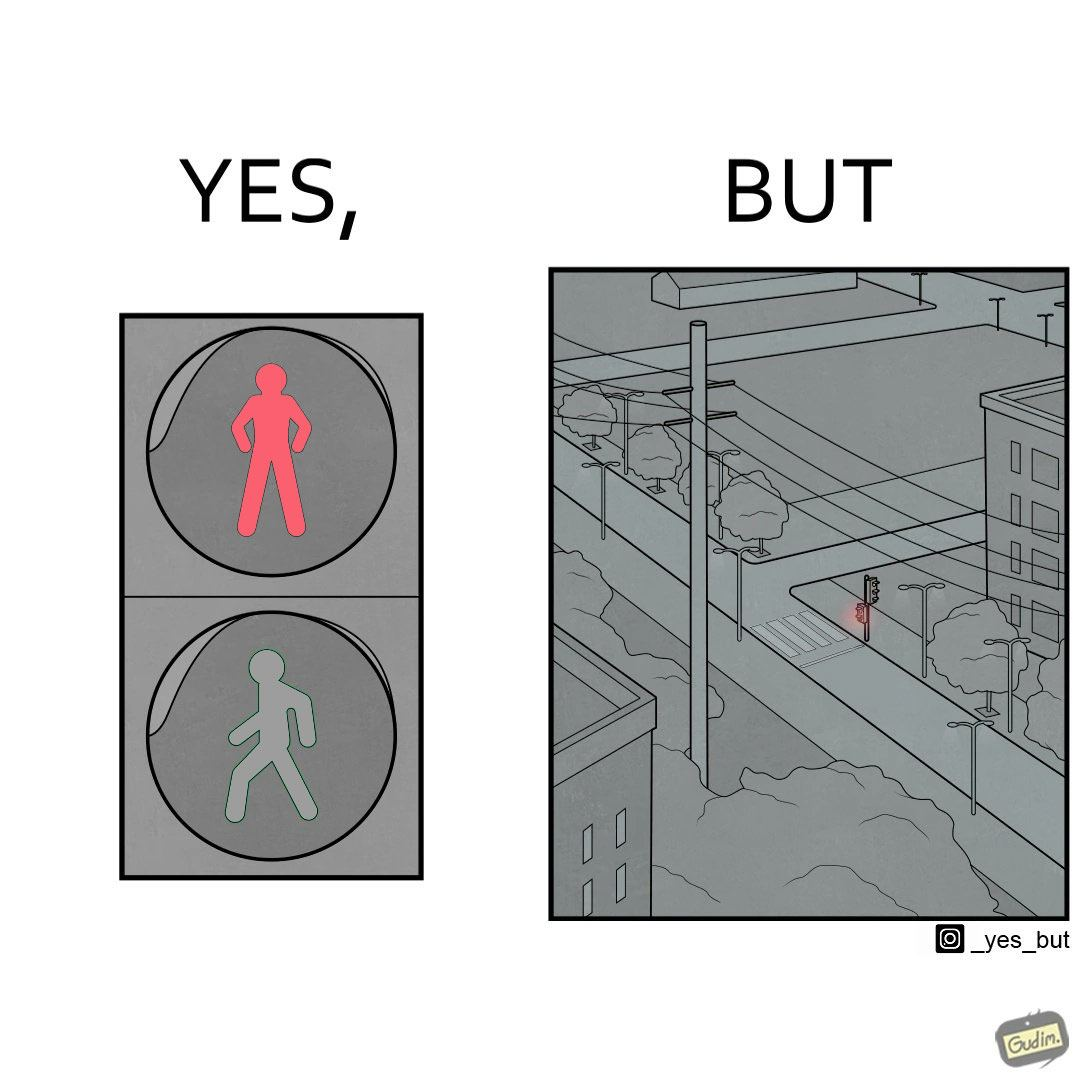Explain the humor or irony in this image. The image is funny, as the traffic light for pedestrains is red, even though it is at a zebra crossing, which does not need a red light for stopping a pedestrain from crossing. Also, there are no people or vehicles around, which makes the image even funnier. 